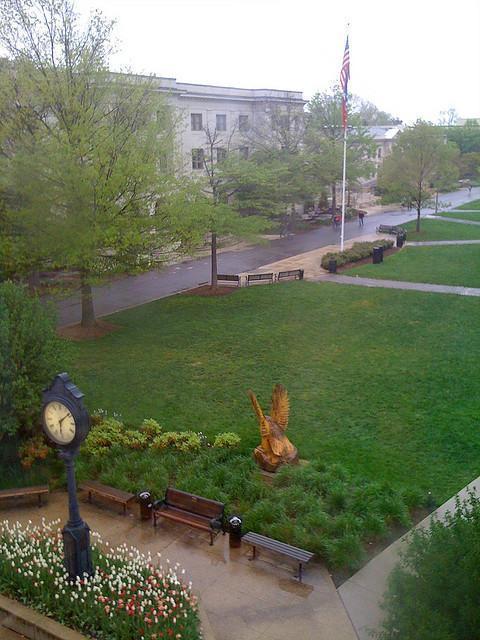What might someone need if they are walking by this clock?
From the following set of four choices, select the accurate answer to respond to the question.
Options: Umbrella, dog, watch, snacks. Umbrella. 